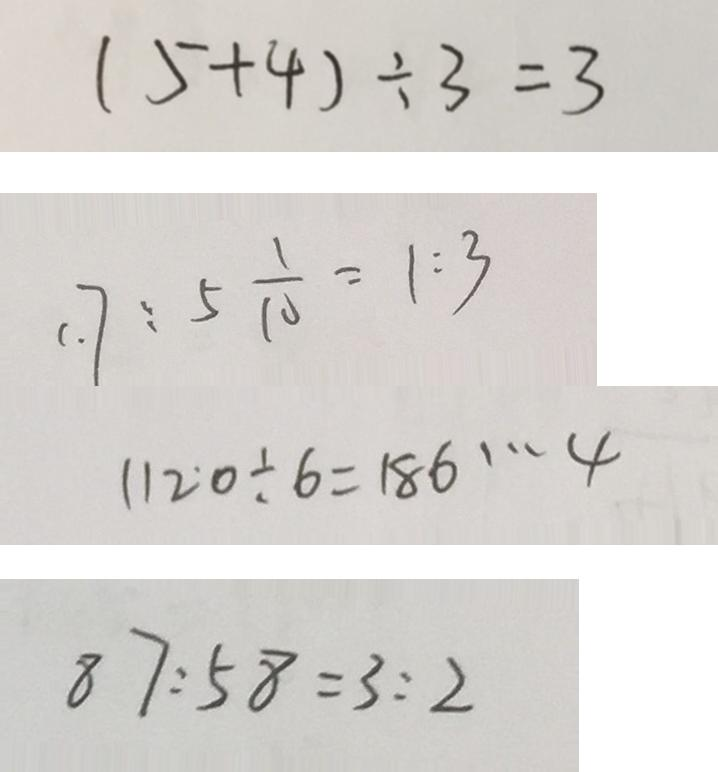<formula> <loc_0><loc_0><loc_500><loc_500>( 5 + 4 ) \div 3 = 3 
 1 . 7 : 5 \frac { 1 } { 1 0 } = 1 : 3 
 1 1 2 ^ { \cdot } 0 \div 6 = 1 8 6 \cdots 4 
 8 7 : 5 8 = 3 : 2</formula> 